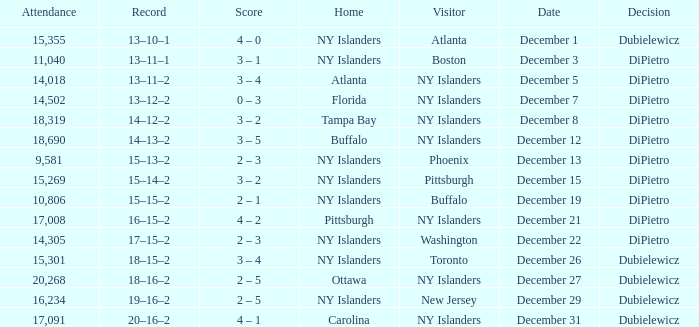Name the date for attendance more than 20,268 None. 